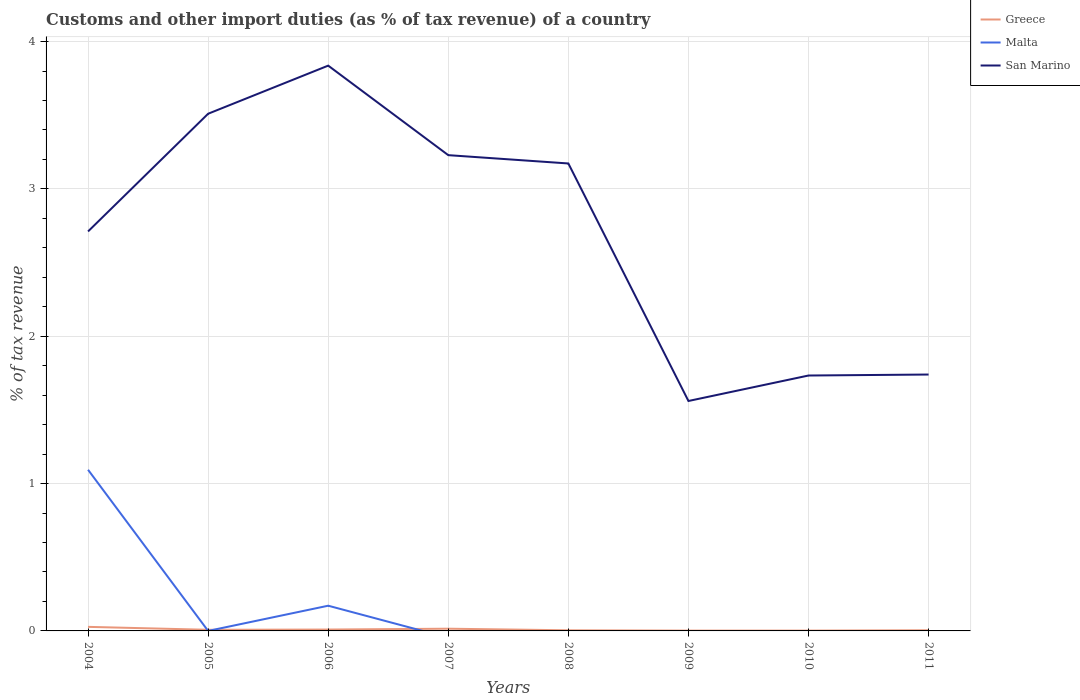How many different coloured lines are there?
Make the answer very short. 3. Does the line corresponding to Greece intersect with the line corresponding to San Marino?
Give a very brief answer. No. Across all years, what is the maximum percentage of tax revenue from customs in San Marino?
Make the answer very short. 1.56. What is the total percentage of tax revenue from customs in San Marino in the graph?
Offer a terse response. -1.13. What is the difference between the highest and the second highest percentage of tax revenue from customs in Greece?
Ensure brevity in your answer.  0.03. What is the difference between the highest and the lowest percentage of tax revenue from customs in Malta?
Make the answer very short. 2. Is the percentage of tax revenue from customs in Malta strictly greater than the percentage of tax revenue from customs in Greece over the years?
Give a very brief answer. No. How many years are there in the graph?
Ensure brevity in your answer.  8. What is the difference between two consecutive major ticks on the Y-axis?
Your answer should be compact. 1. Does the graph contain any zero values?
Keep it short and to the point. Yes. How many legend labels are there?
Give a very brief answer. 3. What is the title of the graph?
Your answer should be very brief. Customs and other import duties (as % of tax revenue) of a country. Does "Uruguay" appear as one of the legend labels in the graph?
Your response must be concise. No. What is the label or title of the X-axis?
Offer a very short reply. Years. What is the label or title of the Y-axis?
Your answer should be compact. % of tax revenue. What is the % of tax revenue in Greece in 2004?
Your answer should be very brief. 0.03. What is the % of tax revenue of Malta in 2004?
Provide a succinct answer. 1.09. What is the % of tax revenue in San Marino in 2004?
Give a very brief answer. 2.71. What is the % of tax revenue in Greece in 2005?
Your answer should be compact. 0.01. What is the % of tax revenue of Malta in 2005?
Keep it short and to the point. 6.17825969986944e-10. What is the % of tax revenue of San Marino in 2005?
Your answer should be very brief. 3.51. What is the % of tax revenue in Greece in 2006?
Offer a very short reply. 0.01. What is the % of tax revenue of Malta in 2006?
Provide a succinct answer. 0.17. What is the % of tax revenue of San Marino in 2006?
Provide a short and direct response. 3.84. What is the % of tax revenue of Greece in 2007?
Make the answer very short. 0.02. What is the % of tax revenue in San Marino in 2007?
Your answer should be compact. 3.23. What is the % of tax revenue in Greece in 2008?
Give a very brief answer. 0. What is the % of tax revenue in San Marino in 2008?
Keep it short and to the point. 3.17. What is the % of tax revenue of Greece in 2009?
Offer a very short reply. 0. What is the % of tax revenue of San Marino in 2009?
Your answer should be compact. 1.56. What is the % of tax revenue in Greece in 2010?
Offer a terse response. 0. What is the % of tax revenue in San Marino in 2010?
Give a very brief answer. 1.73. What is the % of tax revenue of Greece in 2011?
Provide a short and direct response. 0. What is the % of tax revenue in Malta in 2011?
Ensure brevity in your answer.  0. What is the % of tax revenue of San Marino in 2011?
Ensure brevity in your answer.  1.74. Across all years, what is the maximum % of tax revenue of Greece?
Make the answer very short. 0.03. Across all years, what is the maximum % of tax revenue of Malta?
Keep it short and to the point. 1.09. Across all years, what is the maximum % of tax revenue in San Marino?
Keep it short and to the point. 3.84. Across all years, what is the minimum % of tax revenue in Greece?
Give a very brief answer. 0. Across all years, what is the minimum % of tax revenue of Malta?
Your response must be concise. 0. Across all years, what is the minimum % of tax revenue in San Marino?
Provide a short and direct response. 1.56. What is the total % of tax revenue of Greece in the graph?
Provide a succinct answer. 0.07. What is the total % of tax revenue of Malta in the graph?
Provide a short and direct response. 1.26. What is the total % of tax revenue of San Marino in the graph?
Your answer should be very brief. 21.49. What is the difference between the % of tax revenue of Greece in 2004 and that in 2005?
Ensure brevity in your answer.  0.02. What is the difference between the % of tax revenue of Malta in 2004 and that in 2005?
Provide a short and direct response. 1.09. What is the difference between the % of tax revenue in San Marino in 2004 and that in 2005?
Offer a very short reply. -0.8. What is the difference between the % of tax revenue of Greece in 2004 and that in 2006?
Ensure brevity in your answer.  0.02. What is the difference between the % of tax revenue in Malta in 2004 and that in 2006?
Keep it short and to the point. 0.92. What is the difference between the % of tax revenue in San Marino in 2004 and that in 2006?
Your answer should be very brief. -1.13. What is the difference between the % of tax revenue of Greece in 2004 and that in 2007?
Offer a very short reply. 0.01. What is the difference between the % of tax revenue of San Marino in 2004 and that in 2007?
Your response must be concise. -0.52. What is the difference between the % of tax revenue in Greece in 2004 and that in 2008?
Your answer should be compact. 0.02. What is the difference between the % of tax revenue in San Marino in 2004 and that in 2008?
Give a very brief answer. -0.46. What is the difference between the % of tax revenue in Greece in 2004 and that in 2009?
Make the answer very short. 0.03. What is the difference between the % of tax revenue of San Marino in 2004 and that in 2009?
Provide a short and direct response. 1.15. What is the difference between the % of tax revenue in Greece in 2004 and that in 2010?
Ensure brevity in your answer.  0.03. What is the difference between the % of tax revenue in San Marino in 2004 and that in 2010?
Your answer should be compact. 0.98. What is the difference between the % of tax revenue in Greece in 2004 and that in 2011?
Provide a succinct answer. 0.02. What is the difference between the % of tax revenue in San Marino in 2004 and that in 2011?
Your answer should be very brief. 0.97. What is the difference between the % of tax revenue of Greece in 2005 and that in 2006?
Ensure brevity in your answer.  -0. What is the difference between the % of tax revenue of Malta in 2005 and that in 2006?
Offer a very short reply. -0.17. What is the difference between the % of tax revenue in San Marino in 2005 and that in 2006?
Your answer should be compact. -0.33. What is the difference between the % of tax revenue of Greece in 2005 and that in 2007?
Your answer should be compact. -0.01. What is the difference between the % of tax revenue of San Marino in 2005 and that in 2007?
Your answer should be compact. 0.28. What is the difference between the % of tax revenue of Greece in 2005 and that in 2008?
Provide a succinct answer. 0. What is the difference between the % of tax revenue of San Marino in 2005 and that in 2008?
Give a very brief answer. 0.34. What is the difference between the % of tax revenue of Greece in 2005 and that in 2009?
Provide a succinct answer. 0.01. What is the difference between the % of tax revenue in San Marino in 2005 and that in 2009?
Make the answer very short. 1.95. What is the difference between the % of tax revenue in Greece in 2005 and that in 2010?
Keep it short and to the point. 0.01. What is the difference between the % of tax revenue in San Marino in 2005 and that in 2010?
Your response must be concise. 1.78. What is the difference between the % of tax revenue in Greece in 2005 and that in 2011?
Provide a succinct answer. 0. What is the difference between the % of tax revenue of San Marino in 2005 and that in 2011?
Your response must be concise. 1.77. What is the difference between the % of tax revenue in Greece in 2006 and that in 2007?
Your answer should be compact. -0.01. What is the difference between the % of tax revenue in San Marino in 2006 and that in 2007?
Give a very brief answer. 0.61. What is the difference between the % of tax revenue in Greece in 2006 and that in 2008?
Offer a very short reply. 0.01. What is the difference between the % of tax revenue of San Marino in 2006 and that in 2008?
Make the answer very short. 0.66. What is the difference between the % of tax revenue in Greece in 2006 and that in 2009?
Your response must be concise. 0.01. What is the difference between the % of tax revenue in San Marino in 2006 and that in 2009?
Keep it short and to the point. 2.28. What is the difference between the % of tax revenue in Greece in 2006 and that in 2010?
Provide a short and direct response. 0.01. What is the difference between the % of tax revenue of San Marino in 2006 and that in 2010?
Offer a very short reply. 2.1. What is the difference between the % of tax revenue of Greece in 2006 and that in 2011?
Offer a very short reply. 0. What is the difference between the % of tax revenue of San Marino in 2006 and that in 2011?
Ensure brevity in your answer.  2.1. What is the difference between the % of tax revenue of Greece in 2007 and that in 2008?
Offer a terse response. 0.01. What is the difference between the % of tax revenue of San Marino in 2007 and that in 2008?
Your answer should be very brief. 0.06. What is the difference between the % of tax revenue of Greece in 2007 and that in 2009?
Make the answer very short. 0.01. What is the difference between the % of tax revenue of San Marino in 2007 and that in 2009?
Your response must be concise. 1.67. What is the difference between the % of tax revenue of Greece in 2007 and that in 2010?
Keep it short and to the point. 0.01. What is the difference between the % of tax revenue of San Marino in 2007 and that in 2010?
Your answer should be very brief. 1.5. What is the difference between the % of tax revenue in Greece in 2007 and that in 2011?
Offer a very short reply. 0.01. What is the difference between the % of tax revenue in San Marino in 2007 and that in 2011?
Provide a succinct answer. 1.49. What is the difference between the % of tax revenue in Greece in 2008 and that in 2009?
Your response must be concise. 0. What is the difference between the % of tax revenue in San Marino in 2008 and that in 2009?
Provide a succinct answer. 1.61. What is the difference between the % of tax revenue of Greece in 2008 and that in 2010?
Provide a succinct answer. 0. What is the difference between the % of tax revenue in San Marino in 2008 and that in 2010?
Your answer should be compact. 1.44. What is the difference between the % of tax revenue in Greece in 2008 and that in 2011?
Offer a very short reply. -0. What is the difference between the % of tax revenue in San Marino in 2008 and that in 2011?
Offer a terse response. 1.43. What is the difference between the % of tax revenue in Greece in 2009 and that in 2010?
Your response must be concise. -0. What is the difference between the % of tax revenue of San Marino in 2009 and that in 2010?
Ensure brevity in your answer.  -0.17. What is the difference between the % of tax revenue of Greece in 2009 and that in 2011?
Your response must be concise. -0. What is the difference between the % of tax revenue in San Marino in 2009 and that in 2011?
Make the answer very short. -0.18. What is the difference between the % of tax revenue of Greece in 2010 and that in 2011?
Offer a terse response. -0. What is the difference between the % of tax revenue of San Marino in 2010 and that in 2011?
Offer a terse response. -0.01. What is the difference between the % of tax revenue of Greece in 2004 and the % of tax revenue of Malta in 2005?
Provide a short and direct response. 0.03. What is the difference between the % of tax revenue in Greece in 2004 and the % of tax revenue in San Marino in 2005?
Your answer should be compact. -3.48. What is the difference between the % of tax revenue of Malta in 2004 and the % of tax revenue of San Marino in 2005?
Provide a short and direct response. -2.42. What is the difference between the % of tax revenue of Greece in 2004 and the % of tax revenue of Malta in 2006?
Provide a succinct answer. -0.14. What is the difference between the % of tax revenue of Greece in 2004 and the % of tax revenue of San Marino in 2006?
Your answer should be very brief. -3.81. What is the difference between the % of tax revenue of Malta in 2004 and the % of tax revenue of San Marino in 2006?
Offer a very short reply. -2.74. What is the difference between the % of tax revenue of Greece in 2004 and the % of tax revenue of San Marino in 2007?
Your answer should be compact. -3.2. What is the difference between the % of tax revenue of Malta in 2004 and the % of tax revenue of San Marino in 2007?
Provide a short and direct response. -2.14. What is the difference between the % of tax revenue of Greece in 2004 and the % of tax revenue of San Marino in 2008?
Keep it short and to the point. -3.15. What is the difference between the % of tax revenue of Malta in 2004 and the % of tax revenue of San Marino in 2008?
Make the answer very short. -2.08. What is the difference between the % of tax revenue of Greece in 2004 and the % of tax revenue of San Marino in 2009?
Give a very brief answer. -1.53. What is the difference between the % of tax revenue in Malta in 2004 and the % of tax revenue in San Marino in 2009?
Provide a short and direct response. -0.47. What is the difference between the % of tax revenue of Greece in 2004 and the % of tax revenue of San Marino in 2010?
Make the answer very short. -1.71. What is the difference between the % of tax revenue in Malta in 2004 and the % of tax revenue in San Marino in 2010?
Provide a short and direct response. -0.64. What is the difference between the % of tax revenue in Greece in 2004 and the % of tax revenue in San Marino in 2011?
Make the answer very short. -1.71. What is the difference between the % of tax revenue of Malta in 2004 and the % of tax revenue of San Marino in 2011?
Offer a terse response. -0.65. What is the difference between the % of tax revenue of Greece in 2005 and the % of tax revenue of Malta in 2006?
Make the answer very short. -0.16. What is the difference between the % of tax revenue of Greece in 2005 and the % of tax revenue of San Marino in 2006?
Ensure brevity in your answer.  -3.83. What is the difference between the % of tax revenue in Malta in 2005 and the % of tax revenue in San Marino in 2006?
Your response must be concise. -3.84. What is the difference between the % of tax revenue in Greece in 2005 and the % of tax revenue in San Marino in 2007?
Your answer should be very brief. -3.22. What is the difference between the % of tax revenue of Malta in 2005 and the % of tax revenue of San Marino in 2007?
Give a very brief answer. -3.23. What is the difference between the % of tax revenue in Greece in 2005 and the % of tax revenue in San Marino in 2008?
Give a very brief answer. -3.17. What is the difference between the % of tax revenue in Malta in 2005 and the % of tax revenue in San Marino in 2008?
Keep it short and to the point. -3.17. What is the difference between the % of tax revenue in Greece in 2005 and the % of tax revenue in San Marino in 2009?
Provide a short and direct response. -1.55. What is the difference between the % of tax revenue of Malta in 2005 and the % of tax revenue of San Marino in 2009?
Your answer should be very brief. -1.56. What is the difference between the % of tax revenue of Greece in 2005 and the % of tax revenue of San Marino in 2010?
Give a very brief answer. -1.73. What is the difference between the % of tax revenue of Malta in 2005 and the % of tax revenue of San Marino in 2010?
Your answer should be compact. -1.73. What is the difference between the % of tax revenue in Greece in 2005 and the % of tax revenue in San Marino in 2011?
Make the answer very short. -1.73. What is the difference between the % of tax revenue in Malta in 2005 and the % of tax revenue in San Marino in 2011?
Your answer should be very brief. -1.74. What is the difference between the % of tax revenue of Greece in 2006 and the % of tax revenue of San Marino in 2007?
Your answer should be compact. -3.22. What is the difference between the % of tax revenue of Malta in 2006 and the % of tax revenue of San Marino in 2007?
Offer a terse response. -3.06. What is the difference between the % of tax revenue in Greece in 2006 and the % of tax revenue in San Marino in 2008?
Provide a short and direct response. -3.16. What is the difference between the % of tax revenue of Malta in 2006 and the % of tax revenue of San Marino in 2008?
Keep it short and to the point. -3. What is the difference between the % of tax revenue in Greece in 2006 and the % of tax revenue in San Marino in 2009?
Your answer should be compact. -1.55. What is the difference between the % of tax revenue in Malta in 2006 and the % of tax revenue in San Marino in 2009?
Give a very brief answer. -1.39. What is the difference between the % of tax revenue of Greece in 2006 and the % of tax revenue of San Marino in 2010?
Give a very brief answer. -1.72. What is the difference between the % of tax revenue of Malta in 2006 and the % of tax revenue of San Marino in 2010?
Keep it short and to the point. -1.56. What is the difference between the % of tax revenue in Greece in 2006 and the % of tax revenue in San Marino in 2011?
Provide a short and direct response. -1.73. What is the difference between the % of tax revenue in Malta in 2006 and the % of tax revenue in San Marino in 2011?
Provide a succinct answer. -1.57. What is the difference between the % of tax revenue in Greece in 2007 and the % of tax revenue in San Marino in 2008?
Offer a very short reply. -3.16. What is the difference between the % of tax revenue in Greece in 2007 and the % of tax revenue in San Marino in 2009?
Your response must be concise. -1.55. What is the difference between the % of tax revenue of Greece in 2007 and the % of tax revenue of San Marino in 2010?
Your answer should be compact. -1.72. What is the difference between the % of tax revenue in Greece in 2007 and the % of tax revenue in San Marino in 2011?
Your response must be concise. -1.73. What is the difference between the % of tax revenue in Greece in 2008 and the % of tax revenue in San Marino in 2009?
Keep it short and to the point. -1.56. What is the difference between the % of tax revenue in Greece in 2008 and the % of tax revenue in San Marino in 2010?
Ensure brevity in your answer.  -1.73. What is the difference between the % of tax revenue in Greece in 2008 and the % of tax revenue in San Marino in 2011?
Your answer should be very brief. -1.74. What is the difference between the % of tax revenue of Greece in 2009 and the % of tax revenue of San Marino in 2010?
Offer a terse response. -1.73. What is the difference between the % of tax revenue in Greece in 2009 and the % of tax revenue in San Marino in 2011?
Provide a short and direct response. -1.74. What is the difference between the % of tax revenue of Greece in 2010 and the % of tax revenue of San Marino in 2011?
Give a very brief answer. -1.74. What is the average % of tax revenue in Greece per year?
Your answer should be very brief. 0.01. What is the average % of tax revenue in Malta per year?
Give a very brief answer. 0.16. What is the average % of tax revenue of San Marino per year?
Your response must be concise. 2.69. In the year 2004, what is the difference between the % of tax revenue in Greece and % of tax revenue in Malta?
Your answer should be compact. -1.07. In the year 2004, what is the difference between the % of tax revenue of Greece and % of tax revenue of San Marino?
Provide a short and direct response. -2.68. In the year 2004, what is the difference between the % of tax revenue of Malta and % of tax revenue of San Marino?
Keep it short and to the point. -1.62. In the year 2005, what is the difference between the % of tax revenue in Greece and % of tax revenue in Malta?
Your answer should be compact. 0.01. In the year 2005, what is the difference between the % of tax revenue in Greece and % of tax revenue in San Marino?
Offer a very short reply. -3.5. In the year 2005, what is the difference between the % of tax revenue in Malta and % of tax revenue in San Marino?
Ensure brevity in your answer.  -3.51. In the year 2006, what is the difference between the % of tax revenue in Greece and % of tax revenue in Malta?
Ensure brevity in your answer.  -0.16. In the year 2006, what is the difference between the % of tax revenue of Greece and % of tax revenue of San Marino?
Give a very brief answer. -3.83. In the year 2006, what is the difference between the % of tax revenue of Malta and % of tax revenue of San Marino?
Your answer should be very brief. -3.67. In the year 2007, what is the difference between the % of tax revenue in Greece and % of tax revenue in San Marino?
Your response must be concise. -3.21. In the year 2008, what is the difference between the % of tax revenue in Greece and % of tax revenue in San Marino?
Your answer should be very brief. -3.17. In the year 2009, what is the difference between the % of tax revenue in Greece and % of tax revenue in San Marino?
Make the answer very short. -1.56. In the year 2010, what is the difference between the % of tax revenue in Greece and % of tax revenue in San Marino?
Keep it short and to the point. -1.73. In the year 2011, what is the difference between the % of tax revenue in Greece and % of tax revenue in San Marino?
Your response must be concise. -1.74. What is the ratio of the % of tax revenue of Greece in 2004 to that in 2005?
Provide a short and direct response. 3.61. What is the ratio of the % of tax revenue in Malta in 2004 to that in 2005?
Ensure brevity in your answer.  1.77e+09. What is the ratio of the % of tax revenue of San Marino in 2004 to that in 2005?
Your answer should be very brief. 0.77. What is the ratio of the % of tax revenue of Greece in 2004 to that in 2006?
Make the answer very short. 2.94. What is the ratio of the % of tax revenue of Malta in 2004 to that in 2006?
Offer a terse response. 6.39. What is the ratio of the % of tax revenue of San Marino in 2004 to that in 2006?
Your response must be concise. 0.71. What is the ratio of the % of tax revenue of Greece in 2004 to that in 2007?
Ensure brevity in your answer.  1.83. What is the ratio of the % of tax revenue of San Marino in 2004 to that in 2007?
Offer a terse response. 0.84. What is the ratio of the % of tax revenue of Greece in 2004 to that in 2008?
Ensure brevity in your answer.  6.57. What is the ratio of the % of tax revenue of San Marino in 2004 to that in 2008?
Ensure brevity in your answer.  0.85. What is the ratio of the % of tax revenue in Greece in 2004 to that in 2009?
Your answer should be very brief. 12.49. What is the ratio of the % of tax revenue in San Marino in 2004 to that in 2009?
Ensure brevity in your answer.  1.74. What is the ratio of the % of tax revenue of Greece in 2004 to that in 2010?
Your response must be concise. 12.25. What is the ratio of the % of tax revenue of San Marino in 2004 to that in 2010?
Your answer should be very brief. 1.56. What is the ratio of the % of tax revenue in Greece in 2004 to that in 2011?
Ensure brevity in your answer.  6.13. What is the ratio of the % of tax revenue of San Marino in 2004 to that in 2011?
Your answer should be very brief. 1.56. What is the ratio of the % of tax revenue in Greece in 2005 to that in 2006?
Give a very brief answer. 0.82. What is the ratio of the % of tax revenue in Malta in 2005 to that in 2006?
Provide a succinct answer. 0. What is the ratio of the % of tax revenue in San Marino in 2005 to that in 2006?
Give a very brief answer. 0.91. What is the ratio of the % of tax revenue in Greece in 2005 to that in 2007?
Give a very brief answer. 0.51. What is the ratio of the % of tax revenue of San Marino in 2005 to that in 2007?
Keep it short and to the point. 1.09. What is the ratio of the % of tax revenue in Greece in 2005 to that in 2008?
Offer a very short reply. 1.82. What is the ratio of the % of tax revenue of San Marino in 2005 to that in 2008?
Offer a terse response. 1.11. What is the ratio of the % of tax revenue in Greece in 2005 to that in 2009?
Your response must be concise. 3.46. What is the ratio of the % of tax revenue of San Marino in 2005 to that in 2009?
Provide a succinct answer. 2.25. What is the ratio of the % of tax revenue of Greece in 2005 to that in 2010?
Ensure brevity in your answer.  3.4. What is the ratio of the % of tax revenue of San Marino in 2005 to that in 2010?
Your response must be concise. 2.02. What is the ratio of the % of tax revenue in Greece in 2005 to that in 2011?
Offer a very short reply. 1.7. What is the ratio of the % of tax revenue of San Marino in 2005 to that in 2011?
Make the answer very short. 2.02. What is the ratio of the % of tax revenue in Greece in 2006 to that in 2007?
Offer a terse response. 0.62. What is the ratio of the % of tax revenue in San Marino in 2006 to that in 2007?
Keep it short and to the point. 1.19. What is the ratio of the % of tax revenue in Greece in 2006 to that in 2008?
Keep it short and to the point. 2.23. What is the ratio of the % of tax revenue of San Marino in 2006 to that in 2008?
Provide a short and direct response. 1.21. What is the ratio of the % of tax revenue in Greece in 2006 to that in 2009?
Keep it short and to the point. 4.24. What is the ratio of the % of tax revenue of San Marino in 2006 to that in 2009?
Provide a short and direct response. 2.46. What is the ratio of the % of tax revenue of Greece in 2006 to that in 2010?
Offer a very short reply. 4.16. What is the ratio of the % of tax revenue of San Marino in 2006 to that in 2010?
Your answer should be very brief. 2.21. What is the ratio of the % of tax revenue of Greece in 2006 to that in 2011?
Provide a succinct answer. 2.08. What is the ratio of the % of tax revenue in San Marino in 2006 to that in 2011?
Keep it short and to the point. 2.2. What is the ratio of the % of tax revenue of Greece in 2007 to that in 2008?
Ensure brevity in your answer.  3.6. What is the ratio of the % of tax revenue of San Marino in 2007 to that in 2008?
Provide a succinct answer. 1.02. What is the ratio of the % of tax revenue in Greece in 2007 to that in 2009?
Offer a terse response. 6.84. What is the ratio of the % of tax revenue in San Marino in 2007 to that in 2009?
Give a very brief answer. 2.07. What is the ratio of the % of tax revenue of Greece in 2007 to that in 2010?
Give a very brief answer. 6.71. What is the ratio of the % of tax revenue of San Marino in 2007 to that in 2010?
Give a very brief answer. 1.86. What is the ratio of the % of tax revenue of Greece in 2007 to that in 2011?
Offer a very short reply. 3.36. What is the ratio of the % of tax revenue of San Marino in 2007 to that in 2011?
Make the answer very short. 1.86. What is the ratio of the % of tax revenue of Greece in 2008 to that in 2009?
Your answer should be very brief. 1.9. What is the ratio of the % of tax revenue in San Marino in 2008 to that in 2009?
Provide a short and direct response. 2.03. What is the ratio of the % of tax revenue of Greece in 2008 to that in 2010?
Offer a terse response. 1.86. What is the ratio of the % of tax revenue in San Marino in 2008 to that in 2010?
Keep it short and to the point. 1.83. What is the ratio of the % of tax revenue of Greece in 2008 to that in 2011?
Provide a short and direct response. 0.93. What is the ratio of the % of tax revenue in San Marino in 2008 to that in 2011?
Provide a succinct answer. 1.82. What is the ratio of the % of tax revenue in Greece in 2009 to that in 2010?
Keep it short and to the point. 0.98. What is the ratio of the % of tax revenue of San Marino in 2009 to that in 2010?
Ensure brevity in your answer.  0.9. What is the ratio of the % of tax revenue of Greece in 2009 to that in 2011?
Offer a terse response. 0.49. What is the ratio of the % of tax revenue in San Marino in 2009 to that in 2011?
Make the answer very short. 0.9. What is the ratio of the % of tax revenue of Greece in 2010 to that in 2011?
Give a very brief answer. 0.5. What is the difference between the highest and the second highest % of tax revenue in Greece?
Offer a terse response. 0.01. What is the difference between the highest and the second highest % of tax revenue in Malta?
Your response must be concise. 0.92. What is the difference between the highest and the second highest % of tax revenue in San Marino?
Provide a short and direct response. 0.33. What is the difference between the highest and the lowest % of tax revenue of Greece?
Ensure brevity in your answer.  0.03. What is the difference between the highest and the lowest % of tax revenue of Malta?
Provide a succinct answer. 1.09. What is the difference between the highest and the lowest % of tax revenue of San Marino?
Offer a very short reply. 2.28. 